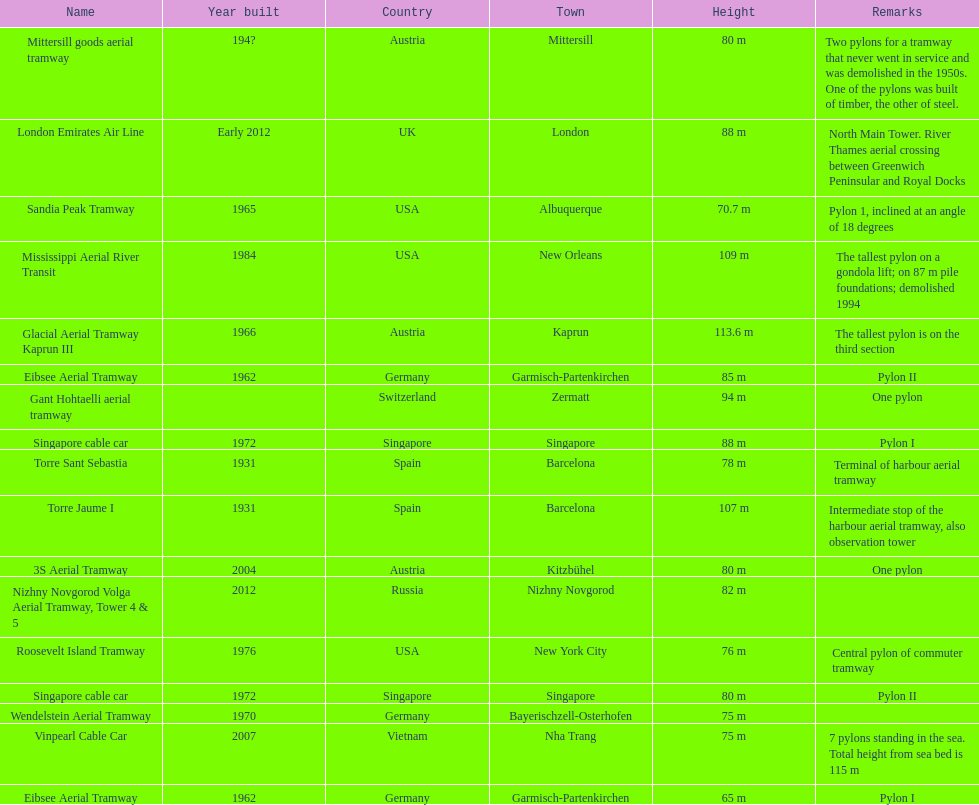Which pylon has the most remarks about it? Mittersill goods aerial tramway. 